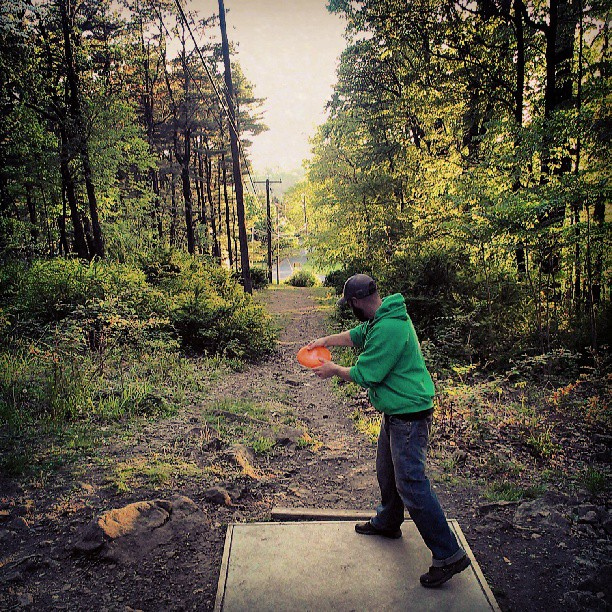<image>What kind of hat is the man wearing? I'm not sure what kind of hat the man is wearing. It appears to be a baseball cap, but it is also possible that there is no hat at all. What kind of hat is the man wearing? It is ambiguous what kind of hat the man is wearing. It can be either a baseball hat or a baseball cap. 